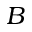<formula> <loc_0><loc_0><loc_500><loc_500>B</formula> 